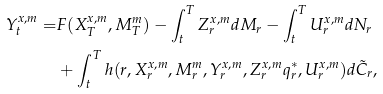<formula> <loc_0><loc_0><loc_500><loc_500>Y ^ { x , m } _ { t } = & F ( X _ { T } ^ { x , m } , M _ { T } ^ { m } ) - \int _ { t } ^ { T } Z _ { r } ^ { x , m } d M _ { r } - \int _ { t } ^ { T } U _ { r } ^ { x , m } d N _ { r } \\ & + \int _ { t } ^ { T } h ( r , X _ { r } ^ { x , m } , M _ { r } ^ { m } , Y _ { r } ^ { x , m } , Z _ { r } ^ { x , m } q _ { r } ^ { * } , U _ { r } ^ { x , m } ) d \tilde { C } _ { r } ,</formula> 